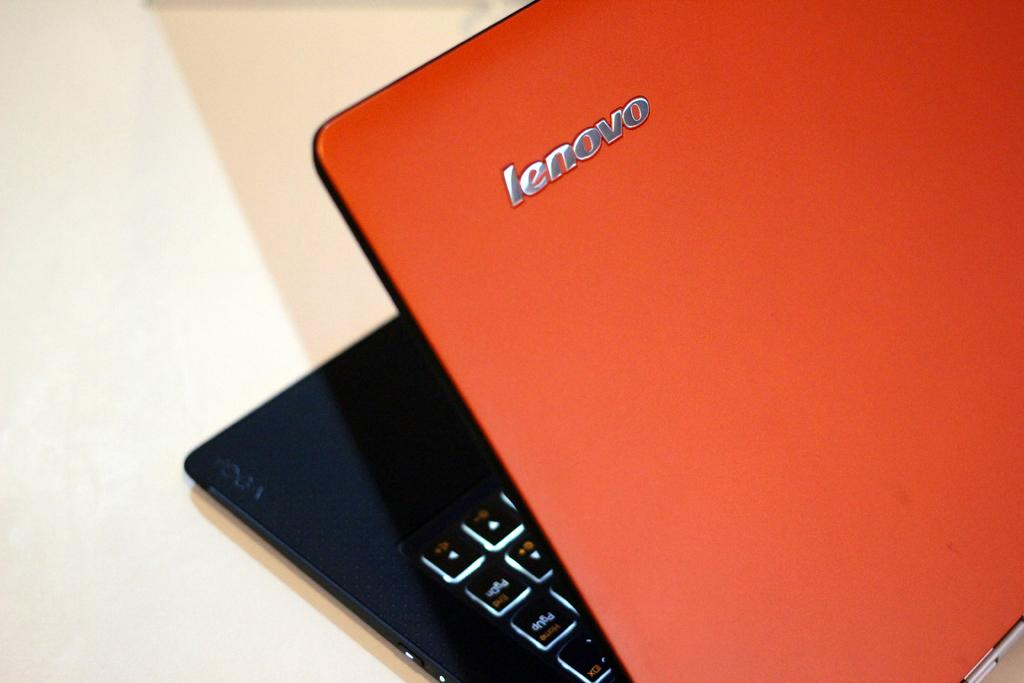<image>
Provide a brief description of the given image. A red Lenovo laptop that is wedged open. 